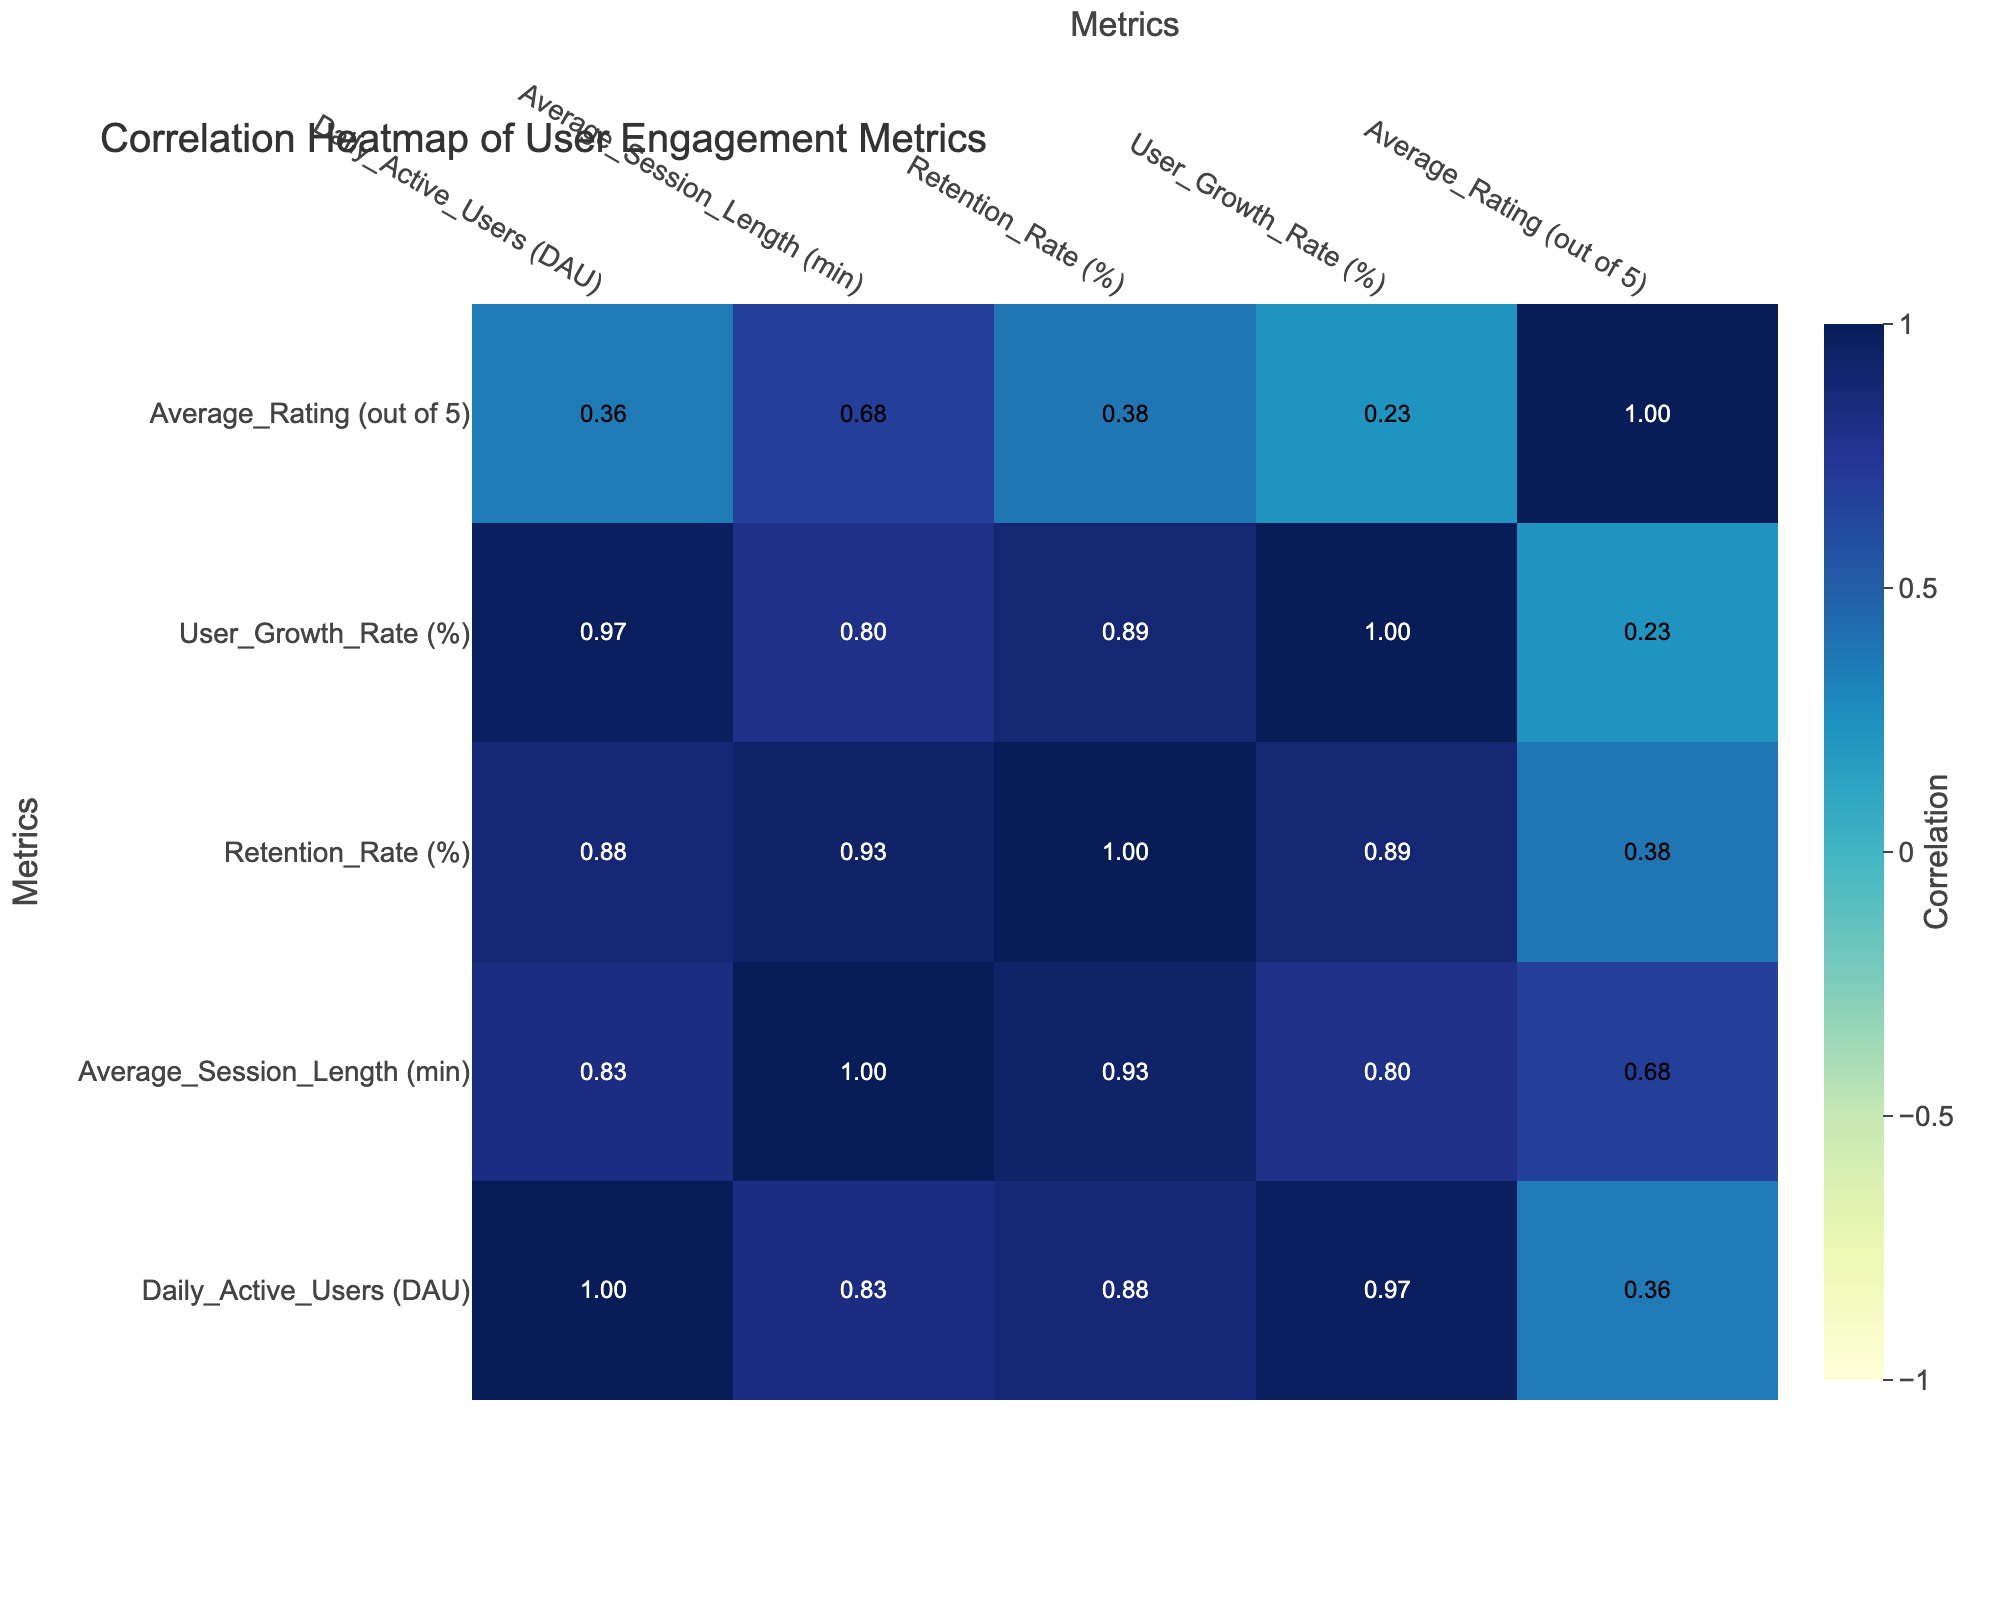What is the Daily Active Users for the Android platform? The table lists the Daily Active Users under the Android platform as 200,000.
Answer: 200000 What is the Average Session Length for iOS users? Referring to the table, the Average Session Length for iOS users is specified as 25 minutes.
Answer: 25 Which platform has the highest Retention Rate? By comparing the Retention Rates, iOS has the highest value at 40%, which is greater than all other platforms listed.
Answer: iOS Is the Average Rating for Web higher than for Windows? Yes, the Average Rating for Web is 4.2, while for Windows, it is 4.0, confirming that Web has a higher Average Rating.
Answer: Yes What is the difference in Daily Active Users between Android and iOS? The Daily Active Users for Android is 200,000 and for iOS is 150,000. The difference is 200,000 - 150,000 = 50,000.
Answer: 50000 What is the average Retention Rate across all platforms? To find this, sum the Retention Rates: 40% + 35% + 30% + 25% + 20% + 32% = 212%. Then divide by the number of platforms (6): 212% / 6 = 35.33%.
Answer: 35.33 Which platform shows the greatest user growth, and what is the percentage? By comparing User Growth Rates, Android has the greatest user growth at 6%, as it is higher than the others.
Answer: Android, 6% If the Average Session Length were to increase by 5 minutes for Cross-Platform, what would it be? The current Average Session Length for Cross-Platform is 18 minutes. Adding 5 minutes results in 18 + 5 = 23 minutes.
Answer: 23 Which two metrics show the strongest positive correlation? By examining the correlation values, Average_Rating and Daily_Active_Users show a notable positive correlation, indicating that higher ratings may relate to more active users.
Answer: Average_Rating and Daily_Active_Users What percentage of Retention Rate does the Mac platform have compared to the average of all platforms? The Retention Rate for Mac is 20%, while the average Retention Rate is 35.33% (calculated earlier). The Mac platform's Retention Rate is therefore 20%/35.33% = 0.566 = 56.6%.
Answer: 56.6% 